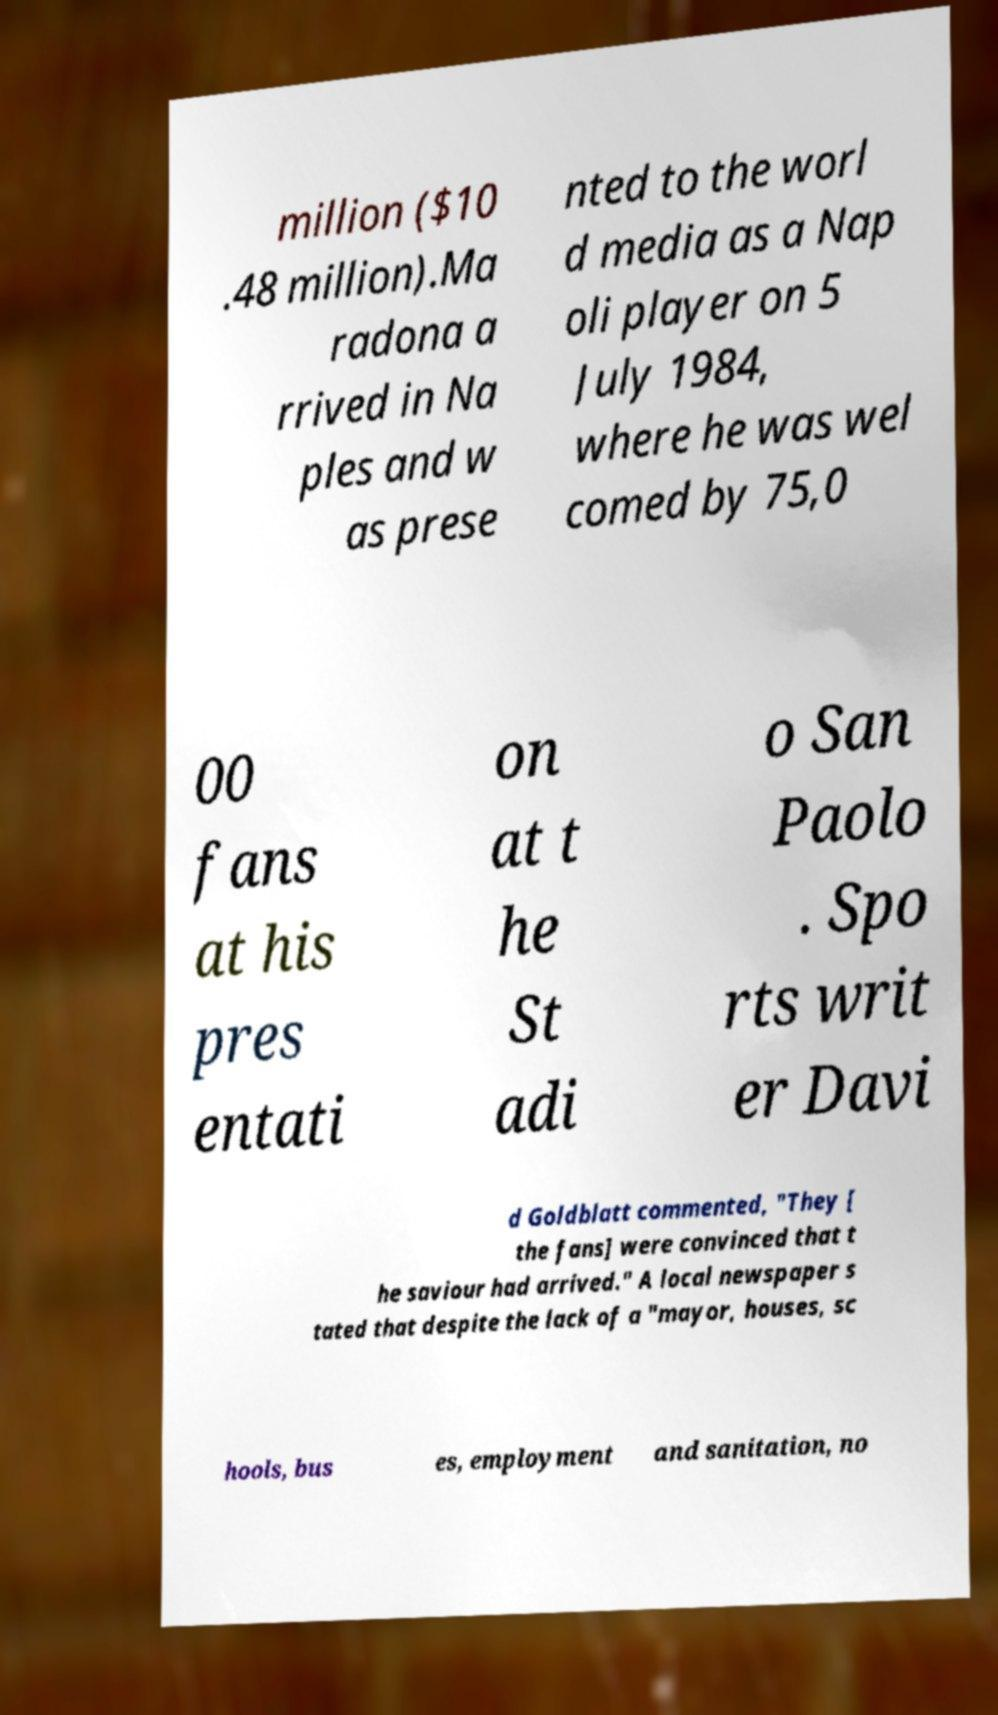Can you accurately transcribe the text from the provided image for me? million ($10 .48 million).Ma radona a rrived in Na ples and w as prese nted to the worl d media as a Nap oli player on 5 July 1984, where he was wel comed by 75,0 00 fans at his pres entati on at t he St adi o San Paolo . Spo rts writ er Davi d Goldblatt commented, "They [ the fans] were convinced that t he saviour had arrived." A local newspaper s tated that despite the lack of a "mayor, houses, sc hools, bus es, employment and sanitation, no 